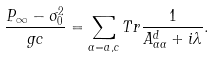Convert formula to latex. <formula><loc_0><loc_0><loc_500><loc_500>\frac { P _ { \infty } - \sigma _ { 0 } ^ { 2 } } { g c } = \sum _ { \alpha = a , c } T r \frac { 1 } { A _ { \alpha \alpha } ^ { d } + i \lambda } .</formula> 